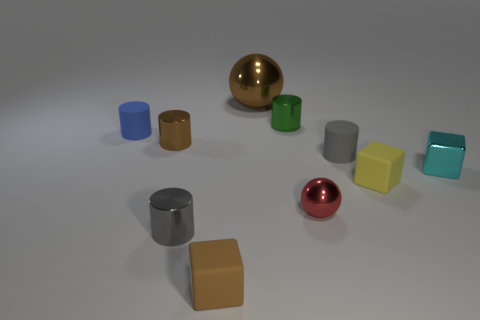Subtract all blue cylinders. How many cylinders are left? 4 Subtract all red balls. How many balls are left? 1 Subtract all spheres. How many objects are left? 8 Subtract all green cylinders. Subtract all red blocks. How many cylinders are left? 4 Subtract all yellow balls. How many cyan cubes are left? 1 Subtract 0 purple cylinders. How many objects are left? 10 Subtract 1 spheres. How many spheres are left? 1 Subtract all gray metallic cylinders. Subtract all tiny yellow matte cubes. How many objects are left? 8 Add 8 balls. How many balls are left? 10 Add 7 large yellow cubes. How many large yellow cubes exist? 7 